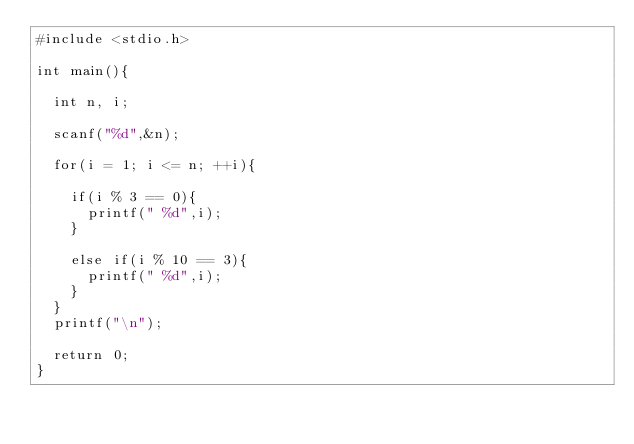<code> <loc_0><loc_0><loc_500><loc_500><_C_>#include <stdio.h>

int main(){
	
	int n, i;
	
	scanf("%d",&n);
	
	for(i = 1; i <= n; ++i){
		
		if(i % 3 == 0){
			printf(" %d",i);
		}
		
		else if(i % 10 == 3){
			printf(" %d",i);
		}
	}
	printf("\n");
	
	return 0;
}</code> 